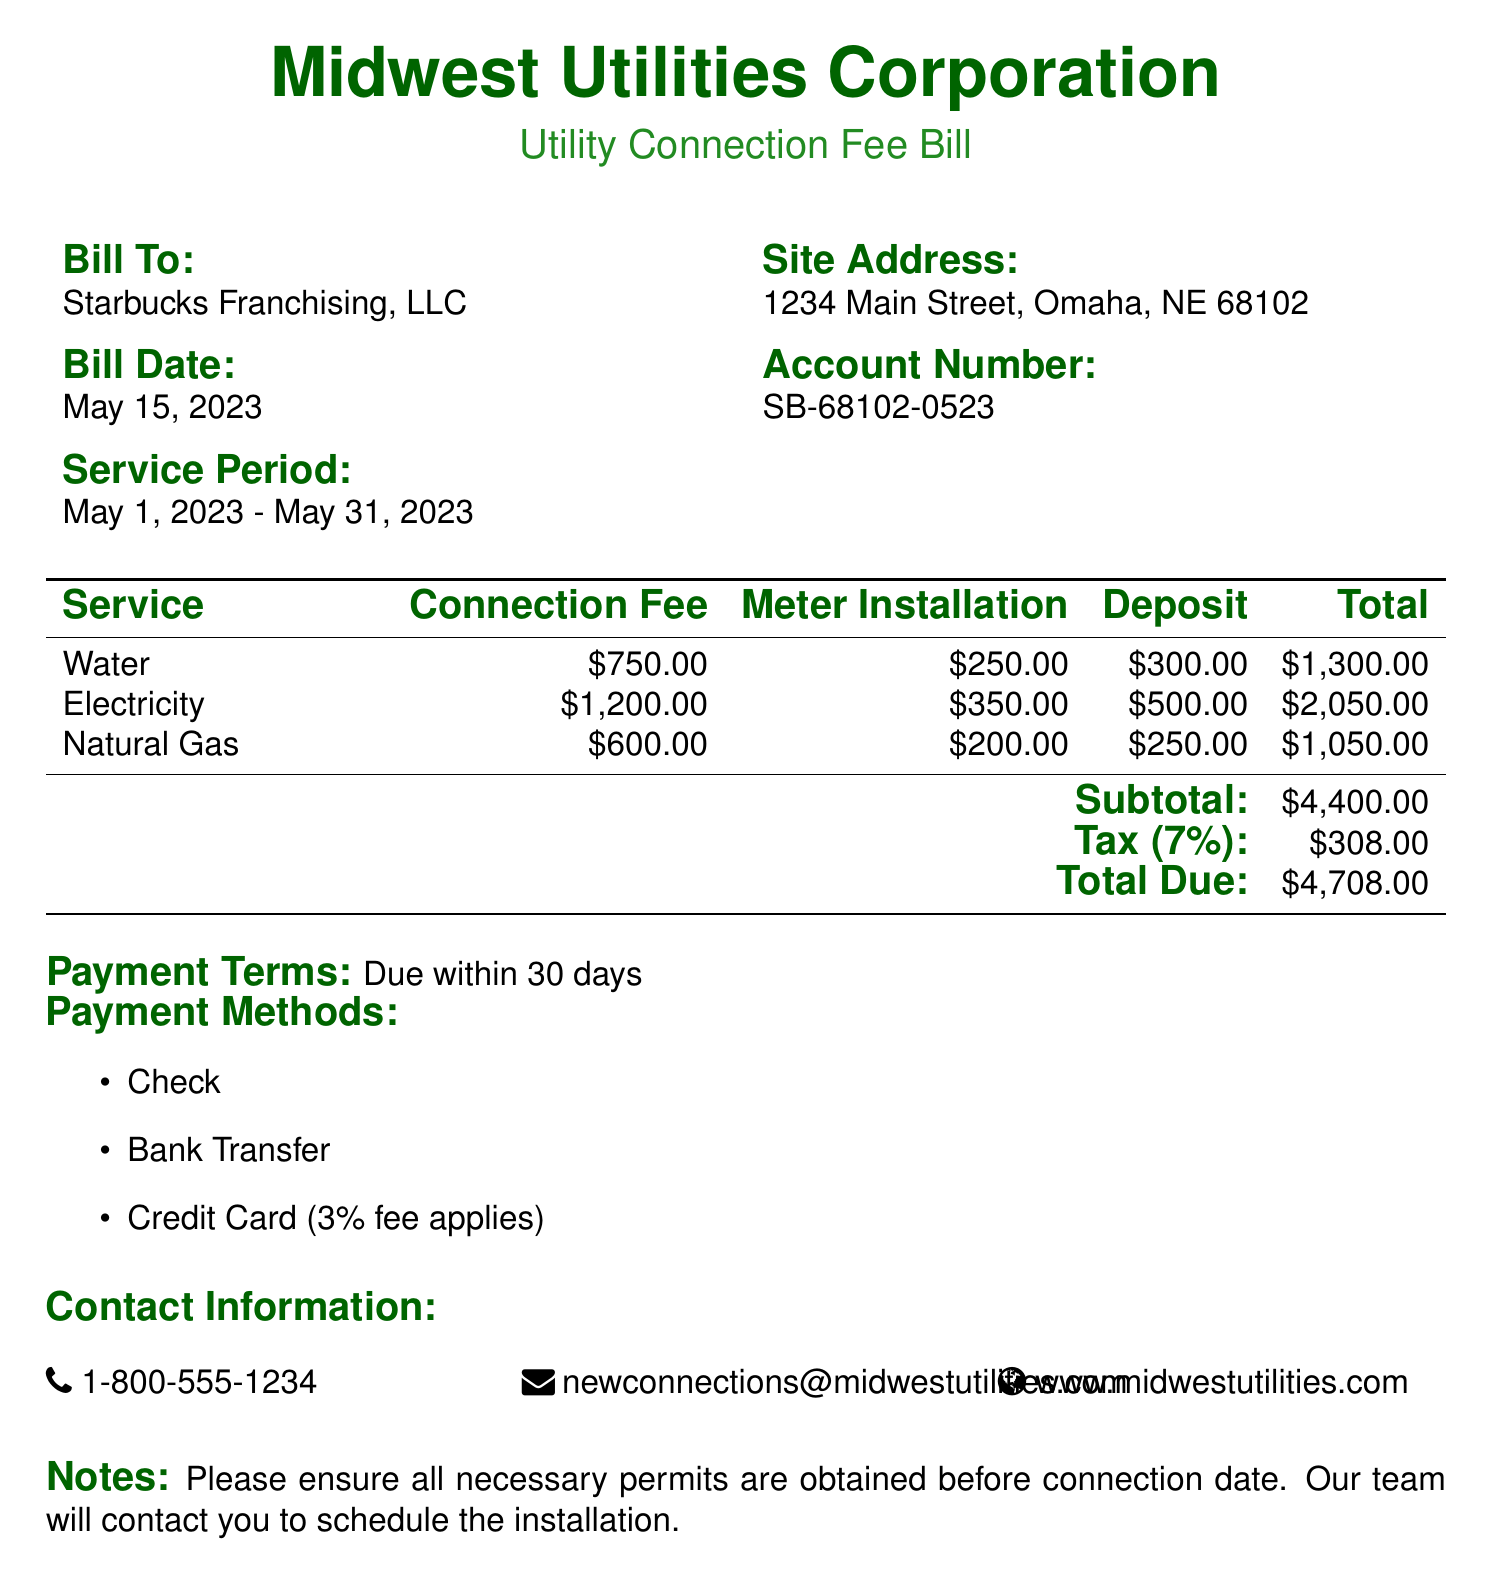What is the total due? The total due is the final amount owed as specified at the bottom of the bill.
Answer: $4,708.00 What is the service period? The service period is clearly indicated in the designated area of the bill.
Answer: May 1, 2023 - May 31, 2023 What is the connection fee for electricity? The connection fee for electricity can be found in the charge breakdown table.
Answer: $1,200.00 What is the tax rate applied? The tax rate is mentioned in the subtotal section of the bill.
Answer: 7% How many methods of payment are offered? The methods of payment are listed in the payment terms section and can be counted.
Answer: 3 What is the deposit for natural gas? The deposit amount for natural gas is shown in the breakdown table.
Answer: $250.00 What is the account number on the bill? The account number is provided in the designated area, associated with the billing address.
Answer: SB-68102-0523 What is the meter installation fee for water? The meter installation fee for water is specified in the service charge breakdown.
Answer: $250.00 When is the payment due? The document mentions a specific period for payment that is clearly stated.
Answer: Within 30 days 